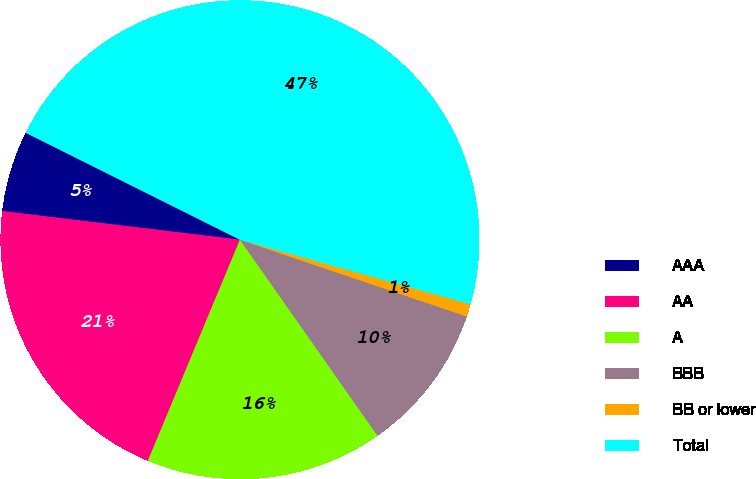<chart> <loc_0><loc_0><loc_500><loc_500><pie_chart><fcel>AAA<fcel>AA<fcel>A<fcel>BBB<fcel>BB or lower<fcel>Total<nl><fcel>5.46%<fcel>20.63%<fcel>16.02%<fcel>10.07%<fcel>0.85%<fcel>46.97%<nl></chart> 